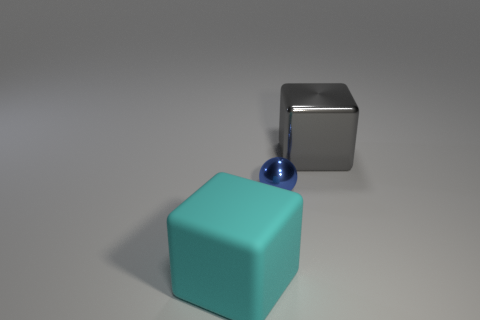Add 3 shiny things. How many objects exist? 6 Subtract all cubes. How many objects are left? 1 Add 3 blue spheres. How many blue spheres are left? 4 Add 1 spheres. How many spheres exist? 2 Subtract 0 yellow balls. How many objects are left? 3 Subtract all purple matte cylinders. Subtract all big cyan matte blocks. How many objects are left? 2 